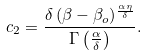Convert formula to latex. <formula><loc_0><loc_0><loc_500><loc_500>c _ { 2 } = \frac { \delta \, ( \beta - \beta _ { o } ) ^ { \frac { \alpha \eta } { \delta } } } { \Gamma \left ( \frac { \alpha } { \delta } \right ) } .</formula> 